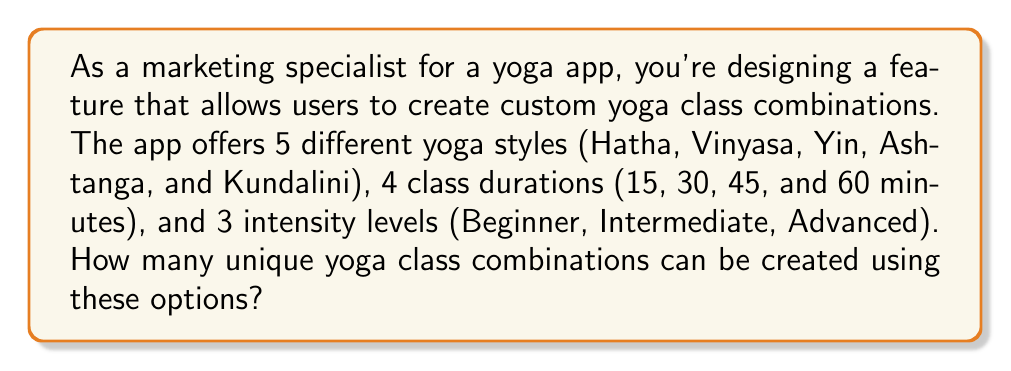Give your solution to this math problem. To solve this problem, we'll use the multiplication principle of counting. This principle states that if we have $n$ independent events, and each event $i$ has $m_i$ possible outcomes, then the total number of possible outcomes for all events is the product of the number of outcomes for each event.

In this case, we have three independent choices:
1. Yoga style: 5 options
2. Class duration: 4 options
3. Intensity level: 3 options

Let's define variables for each choice:
$s =$ number of yoga styles $= 5$
$d =$ number of class durations $= 4$
$i =$ number of intensity levels $= 3$

According to the multiplication principle, the total number of combinations is:

$$ \text{Total combinations} = s \times d \times i $$

Substituting the values:

$$ \text{Total combinations} = 5 \times 4 \times 3 = 60 $$

Therefore, the total number of unique yoga class combinations that can be created is 60.
Answer: 60 unique yoga class combinations 